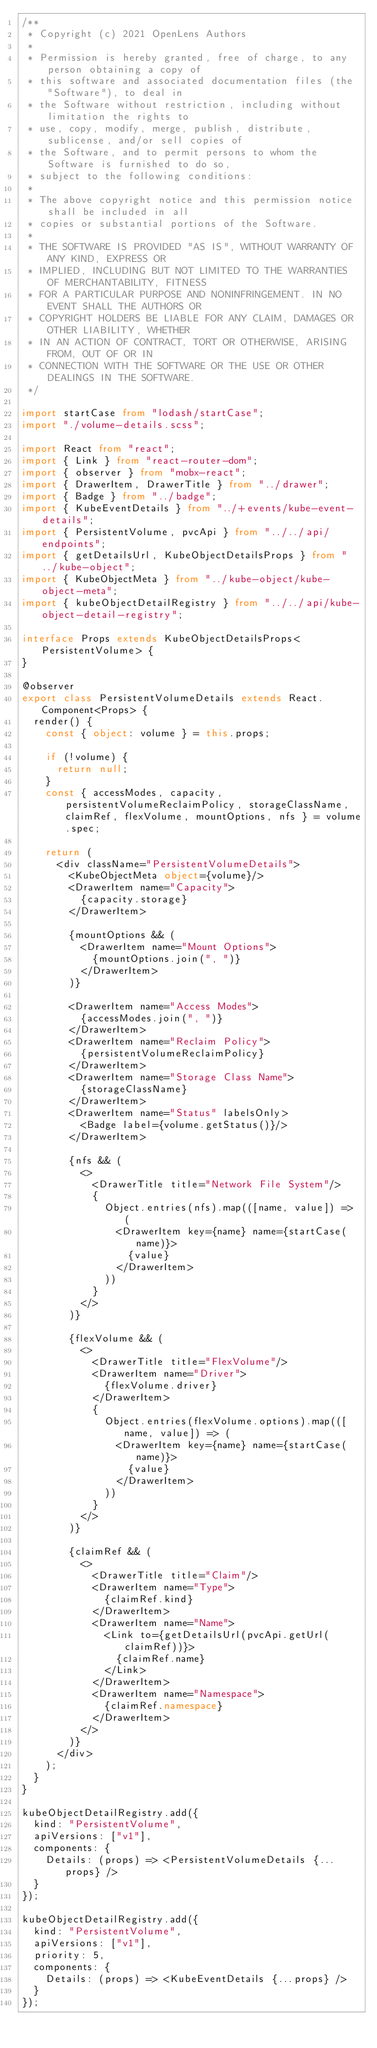Convert code to text. <code><loc_0><loc_0><loc_500><loc_500><_TypeScript_>/**
 * Copyright (c) 2021 OpenLens Authors
 *
 * Permission is hereby granted, free of charge, to any person obtaining a copy of
 * this software and associated documentation files (the "Software"), to deal in
 * the Software without restriction, including without limitation the rights to
 * use, copy, modify, merge, publish, distribute, sublicense, and/or sell copies of
 * the Software, and to permit persons to whom the Software is furnished to do so,
 * subject to the following conditions:
 *
 * The above copyright notice and this permission notice shall be included in all
 * copies or substantial portions of the Software.
 *
 * THE SOFTWARE IS PROVIDED "AS IS", WITHOUT WARRANTY OF ANY KIND, EXPRESS OR
 * IMPLIED, INCLUDING BUT NOT LIMITED TO THE WARRANTIES OF MERCHANTABILITY, FITNESS
 * FOR A PARTICULAR PURPOSE AND NONINFRINGEMENT. IN NO EVENT SHALL THE AUTHORS OR
 * COPYRIGHT HOLDERS BE LIABLE FOR ANY CLAIM, DAMAGES OR OTHER LIABILITY, WHETHER
 * IN AN ACTION OF CONTRACT, TORT OR OTHERWISE, ARISING FROM, OUT OF OR IN
 * CONNECTION WITH THE SOFTWARE OR THE USE OR OTHER DEALINGS IN THE SOFTWARE.
 */

import startCase from "lodash/startCase";
import "./volume-details.scss";

import React from "react";
import { Link } from "react-router-dom";
import { observer } from "mobx-react";
import { DrawerItem, DrawerTitle } from "../drawer";
import { Badge } from "../badge";
import { KubeEventDetails } from "../+events/kube-event-details";
import { PersistentVolume, pvcApi } from "../../api/endpoints";
import { getDetailsUrl, KubeObjectDetailsProps } from "../kube-object";
import { KubeObjectMeta } from "../kube-object/kube-object-meta";
import { kubeObjectDetailRegistry } from "../../api/kube-object-detail-registry";

interface Props extends KubeObjectDetailsProps<PersistentVolume> {
}

@observer
export class PersistentVolumeDetails extends React.Component<Props> {
  render() {
    const { object: volume } = this.props;

    if (!volume) {
      return null;
    }
    const { accessModes, capacity, persistentVolumeReclaimPolicy, storageClassName, claimRef, flexVolume, mountOptions, nfs } = volume.spec;

    return (
      <div className="PersistentVolumeDetails">
        <KubeObjectMeta object={volume}/>
        <DrawerItem name="Capacity">
          {capacity.storage}
        </DrawerItem>

        {mountOptions && (
          <DrawerItem name="Mount Options">
            {mountOptions.join(", ")}
          </DrawerItem>
        )}

        <DrawerItem name="Access Modes">
          {accessModes.join(", ")}
        </DrawerItem>
        <DrawerItem name="Reclaim Policy">
          {persistentVolumeReclaimPolicy}
        </DrawerItem>
        <DrawerItem name="Storage Class Name">
          {storageClassName}
        </DrawerItem>
        <DrawerItem name="Status" labelsOnly>
          <Badge label={volume.getStatus()}/>
        </DrawerItem>

        {nfs && (
          <>
            <DrawerTitle title="Network File System"/>
            {
              Object.entries(nfs).map(([name, value]) => (
                <DrawerItem key={name} name={startCase(name)}>
                  {value}
                </DrawerItem>
              ))
            }
          </>
        )}

        {flexVolume && (
          <>
            <DrawerTitle title="FlexVolume"/>
            <DrawerItem name="Driver">
              {flexVolume.driver}
            </DrawerItem>
            {
              Object.entries(flexVolume.options).map(([name, value]) => (
                <DrawerItem key={name} name={startCase(name)}>
                  {value}
                </DrawerItem>
              ))
            }
          </>
        )}

        {claimRef && (
          <>
            <DrawerTitle title="Claim"/>
            <DrawerItem name="Type">
              {claimRef.kind}
            </DrawerItem>
            <DrawerItem name="Name">
              <Link to={getDetailsUrl(pvcApi.getUrl(claimRef))}>
                {claimRef.name}
              </Link>
            </DrawerItem>
            <DrawerItem name="Namespace">
              {claimRef.namespace}
            </DrawerItem>
          </>
        )}
      </div>
    );
  }
}

kubeObjectDetailRegistry.add({
  kind: "PersistentVolume",
  apiVersions: ["v1"],
  components: {
    Details: (props) => <PersistentVolumeDetails {...props} />
  }
});

kubeObjectDetailRegistry.add({
  kind: "PersistentVolume",
  apiVersions: ["v1"],
  priority: 5,
  components: {
    Details: (props) => <KubeEventDetails {...props} />
  }
});
</code> 